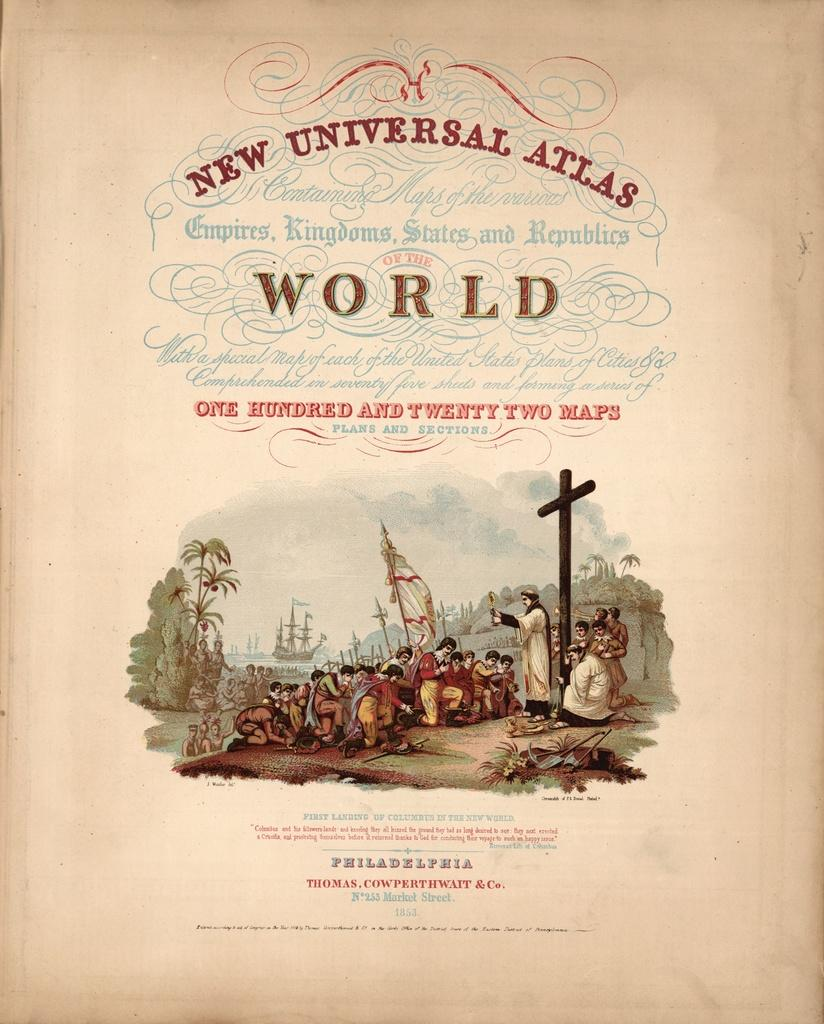<image>
Relay a brief, clear account of the picture shown. page from new universal atlas featuring 122 maps and has picture of priest and settlers 